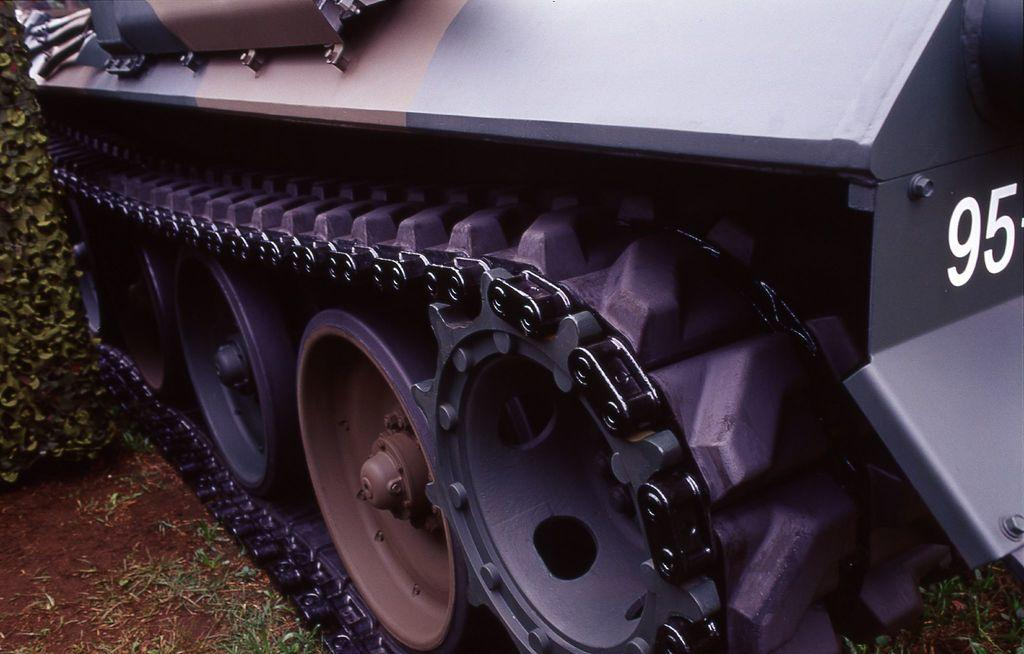What is the main focus of the image? The main focus of the image is vehicle wheels with a chain. Are there any identifiable markings on the vehicle? Yes, there are numbers visible on the vehicle. What type of vegetation can be seen on the left side of the image? There is grass on the left side of the image. What other natural elements are present in the image? There is a plant and soil in the image. What type of bread can be seen in the nest in the image? There is no bread or nest present in the image; it features vehicle wheels with a chain and natural elements like grass, a plant, and soil. 